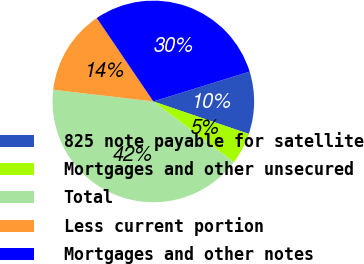Convert chart to OTSL. <chart><loc_0><loc_0><loc_500><loc_500><pie_chart><fcel>825 note payable for satellite<fcel>Mortgages and other unsecured<fcel>Total<fcel>Less current portion<fcel>Mortgages and other notes<nl><fcel>10.01%<fcel>5.06%<fcel>41.57%<fcel>13.66%<fcel>29.7%<nl></chart> 